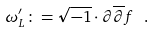<formula> <loc_0><loc_0><loc_500><loc_500>\omega _ { L } ^ { \prime } \colon = \sqrt { - 1 } \cdot \partial \overline { \partial } f \ .</formula> 